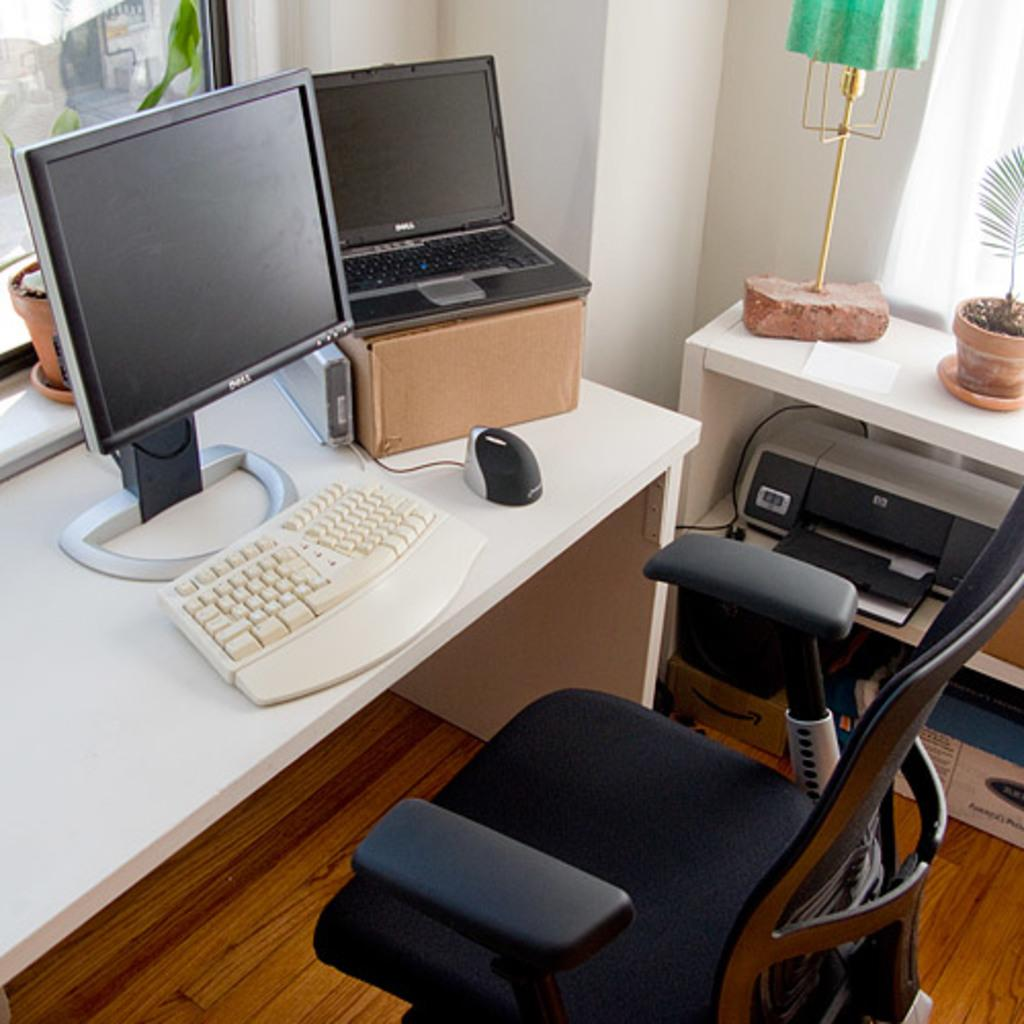What electronic devices are on the table in the image? There is a computer and a laptop on the table in the image. What else can be seen in the image besides the electronic devices? There are plants visible in the image. What device is used for printing in the image? There is a printer in the image. What type of furniture is present in the image? There is a chair in the image. Where is the nest located in the image? There is no nest present in the image. What type of produce is being sold at the market in the image? There is no market or produce present in the image. 